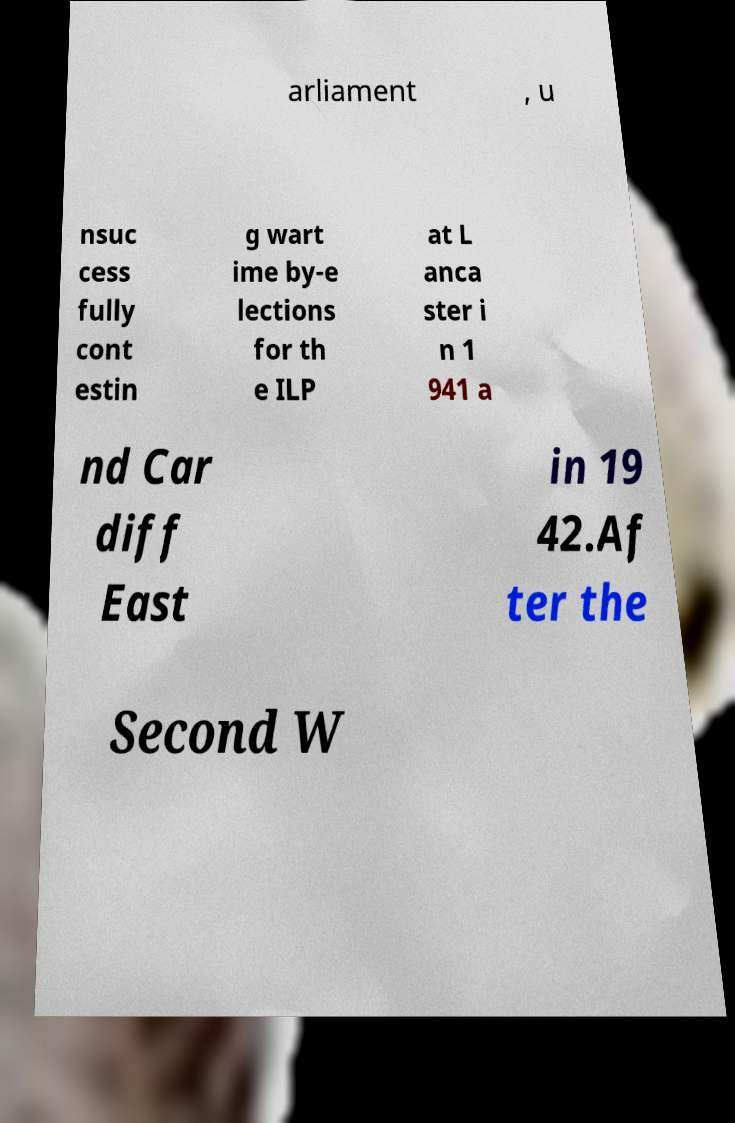Please identify and transcribe the text found in this image. arliament , u nsuc cess fully cont estin g wart ime by-e lections for th e ILP at L anca ster i n 1 941 a nd Car diff East in 19 42.Af ter the Second W 